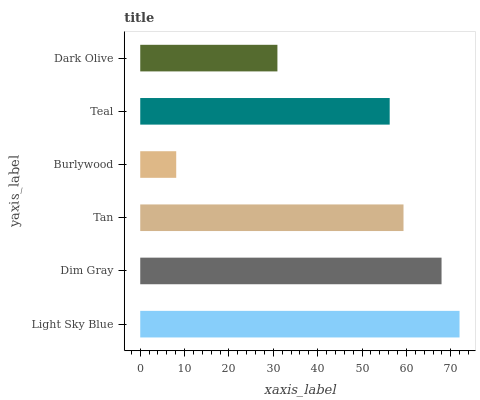Is Burlywood the minimum?
Answer yes or no. Yes. Is Light Sky Blue the maximum?
Answer yes or no. Yes. Is Dim Gray the minimum?
Answer yes or no. No. Is Dim Gray the maximum?
Answer yes or no. No. Is Light Sky Blue greater than Dim Gray?
Answer yes or no. Yes. Is Dim Gray less than Light Sky Blue?
Answer yes or no. Yes. Is Dim Gray greater than Light Sky Blue?
Answer yes or no. No. Is Light Sky Blue less than Dim Gray?
Answer yes or no. No. Is Tan the high median?
Answer yes or no. Yes. Is Teal the low median?
Answer yes or no. Yes. Is Dark Olive the high median?
Answer yes or no. No. Is Tan the low median?
Answer yes or no. No. 